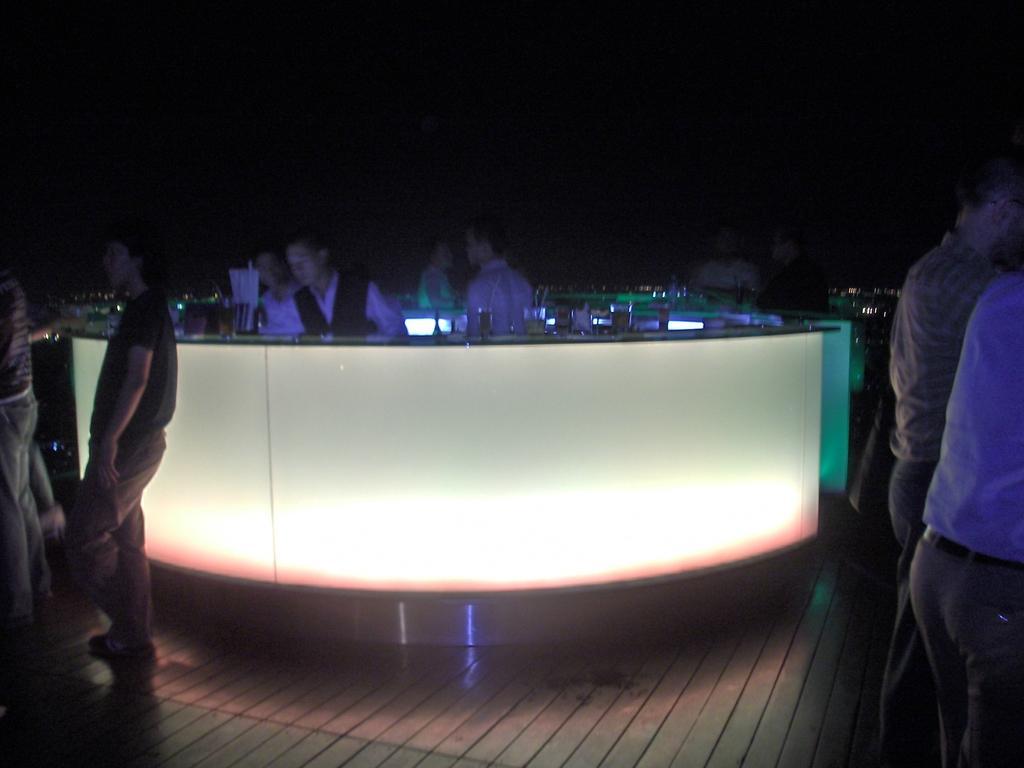Describe this image in one or two sentences. In this image in front there are people standing on the floor. In the center of the image there are tables. On top of the table there are glasses and a few other objects. Behind the table there are people. There are lights. In the background of the image there is sky. 